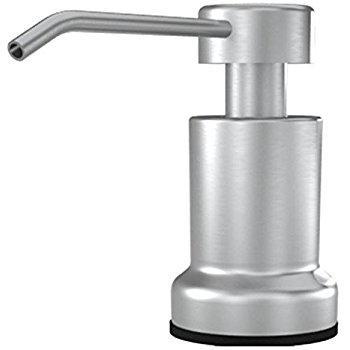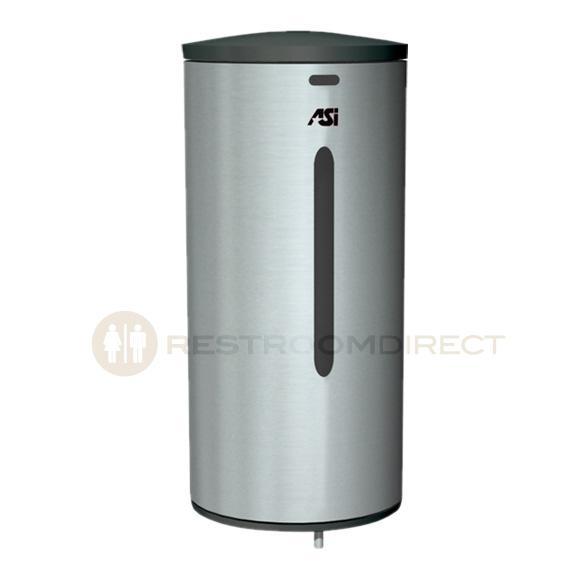The first image is the image on the left, the second image is the image on the right. Evaluate the accuracy of this statement regarding the images: "In one of the images, there is a manual soap dispenser with a nozzle facing left.". Is it true? Answer yes or no. Yes. 